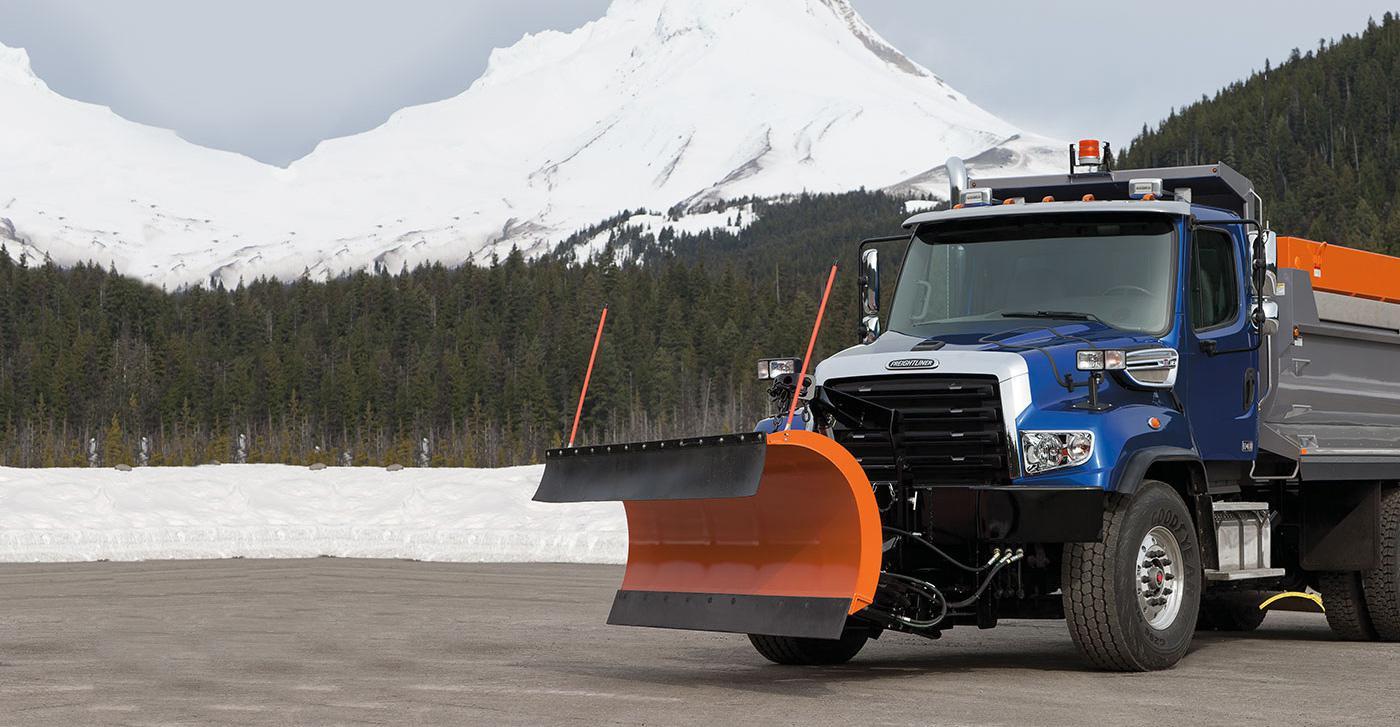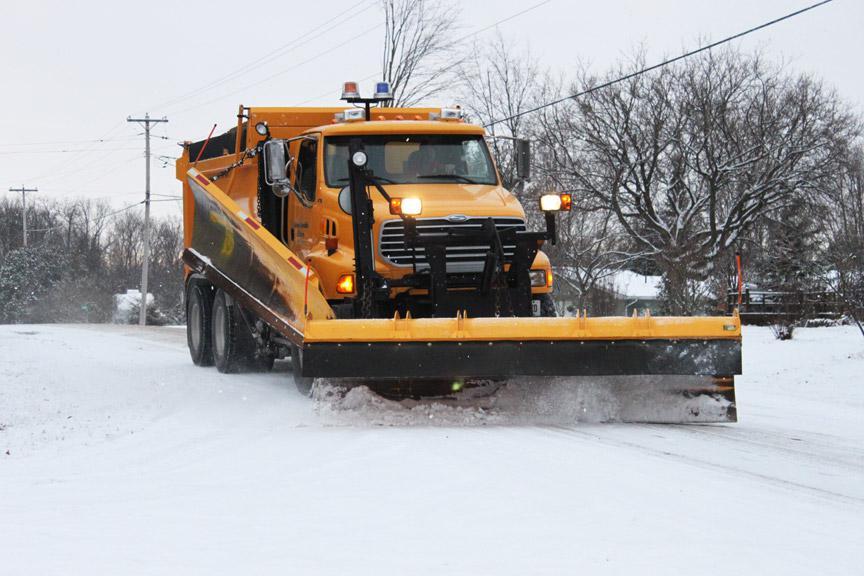The first image is the image on the left, the second image is the image on the right. For the images shown, is this caption "An image features a truck with an orange plow and orange cab on a non-snowy surface." true? Answer yes or no. No. The first image is the image on the left, the second image is the image on the right. For the images displayed, is the sentence "In one image, a white truck with snow blade is in a snowy area near trees, while a second image shows an orange truck with an angled orange blade." factually correct? Answer yes or no. No. 